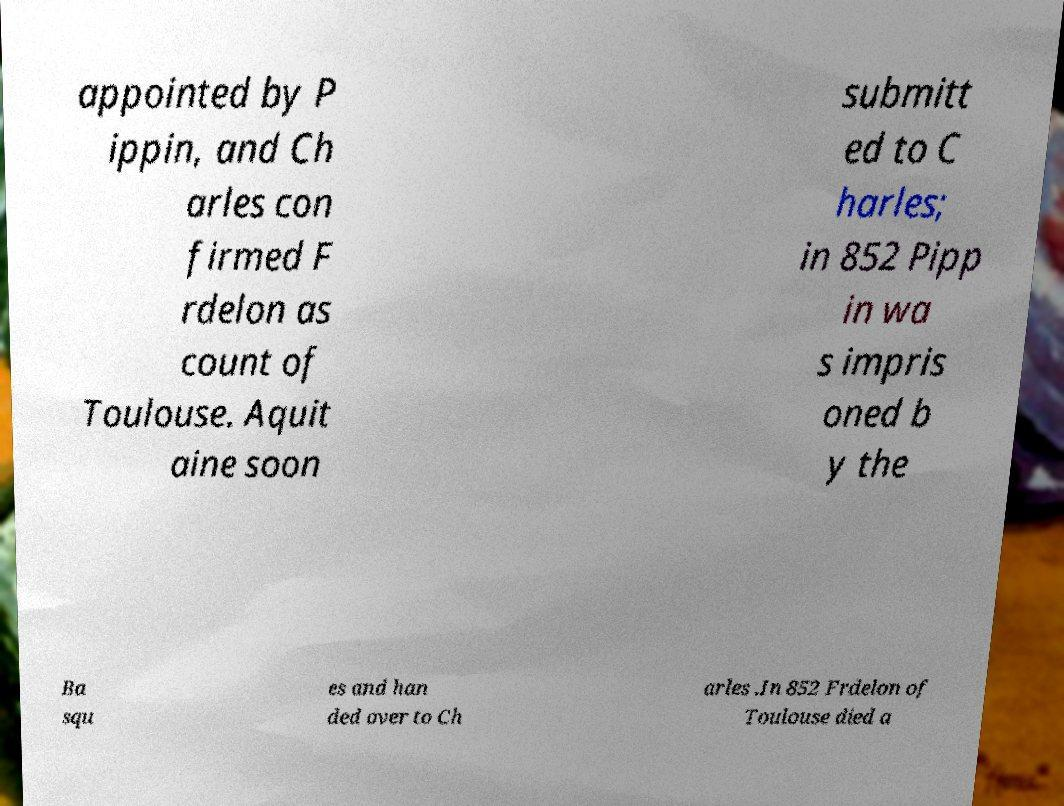Please read and relay the text visible in this image. What does it say? appointed by P ippin, and Ch arles con firmed F rdelon as count of Toulouse. Aquit aine soon submitt ed to C harles; in 852 Pipp in wa s impris oned b y the Ba squ es and han ded over to Ch arles .In 852 Frdelon of Toulouse died a 